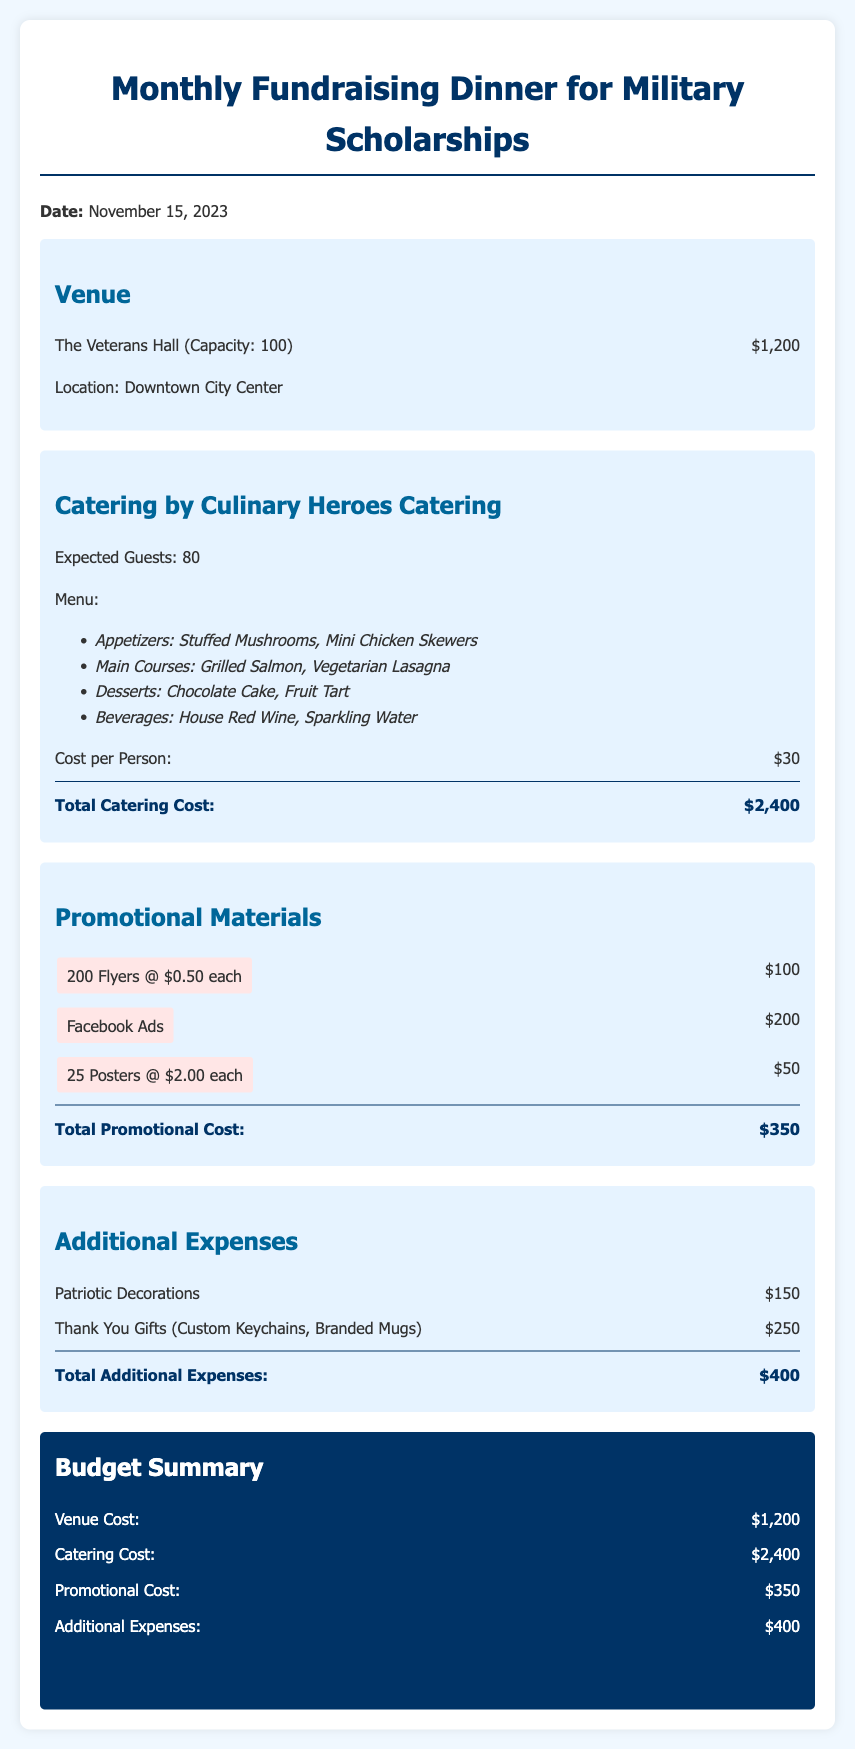What is the venue cost? The venue cost is specified in the document under the Venue section as $1,200.
Answer: $1,200 How much does catering cost per person? The catering cost per person is listed in the Catering section as $30.
Answer: $30 What are the total promotional costs? The total promotional cost is provided at the end of the Promotional Materials section as $350.
Answer: $350 What is the name of the caterer? The caterer's name is stated at the beginning of the Catering section as Culinary Heroes Catering.
Answer: Culinary Heroes Catering What is the total additional expense? The total additional expenses are summed up in the Additional Expenses section, which is $400.
Answer: $400 How many guests are expected? The number of expected guests is mentioned in the Catering section as 80.
Answer: 80 What are the main courses offered? The main courses listed in the menu of the Catering section are Grilled Salmon and Vegetarian Lasagna.
Answer: Grilled Salmon, Vegetarian Lasagna What is the overall budget for the event? The overall budget is presented in the Budget Summary as $4,350.
Answer: $4,350 What is the date of the event? The date of the event is provided at the beginning of the document as November 15, 2023.
Answer: November 15, 2023 